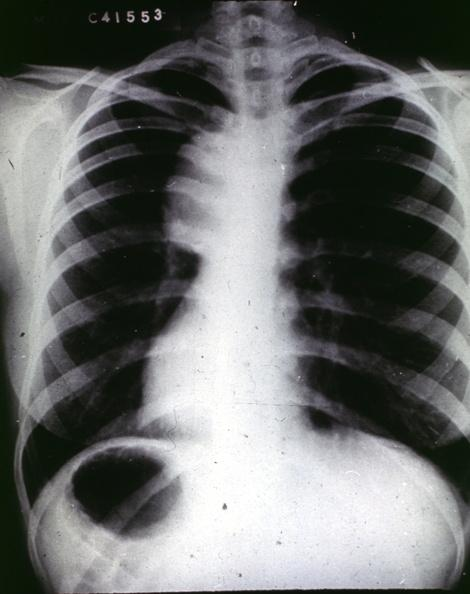what is present?
Answer the question using a single word or phrase. Cardiovascular 